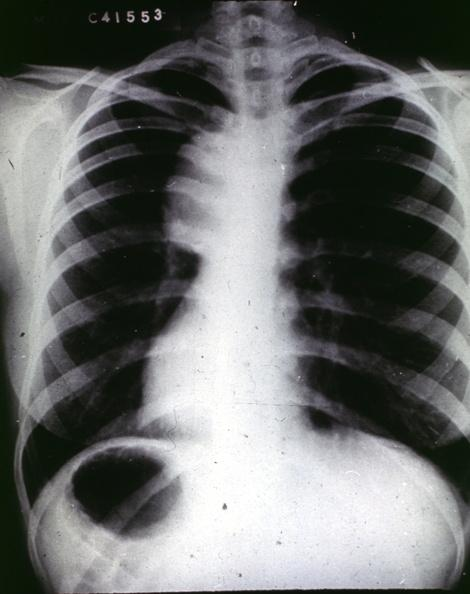what is present?
Answer the question using a single word or phrase. Cardiovascular 